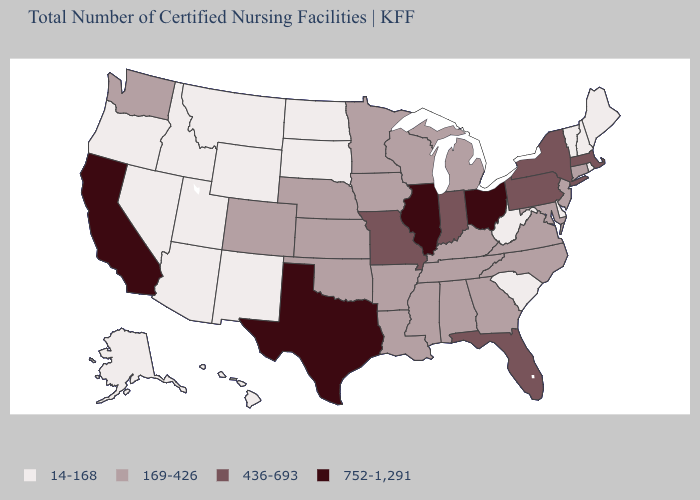What is the value of Wisconsin?
Write a very short answer. 169-426. Does Texas have the highest value in the South?
Be succinct. Yes. What is the value of Ohio?
Write a very short answer. 752-1,291. What is the value of Oregon?
Quick response, please. 14-168. Does the first symbol in the legend represent the smallest category?
Answer briefly. Yes. Among the states that border New Mexico , which have the highest value?
Quick response, please. Texas. What is the lowest value in the USA?
Concise answer only. 14-168. What is the value of North Dakota?
Concise answer only. 14-168. Does the map have missing data?
Short answer required. No. What is the highest value in the West ?
Quick response, please. 752-1,291. What is the lowest value in states that border New Mexico?
Write a very short answer. 14-168. What is the lowest value in the USA?
Be succinct. 14-168. What is the value of Maryland?
Give a very brief answer. 169-426. What is the value of New York?
Keep it brief. 436-693. Name the states that have a value in the range 752-1,291?
Give a very brief answer. California, Illinois, Ohio, Texas. 